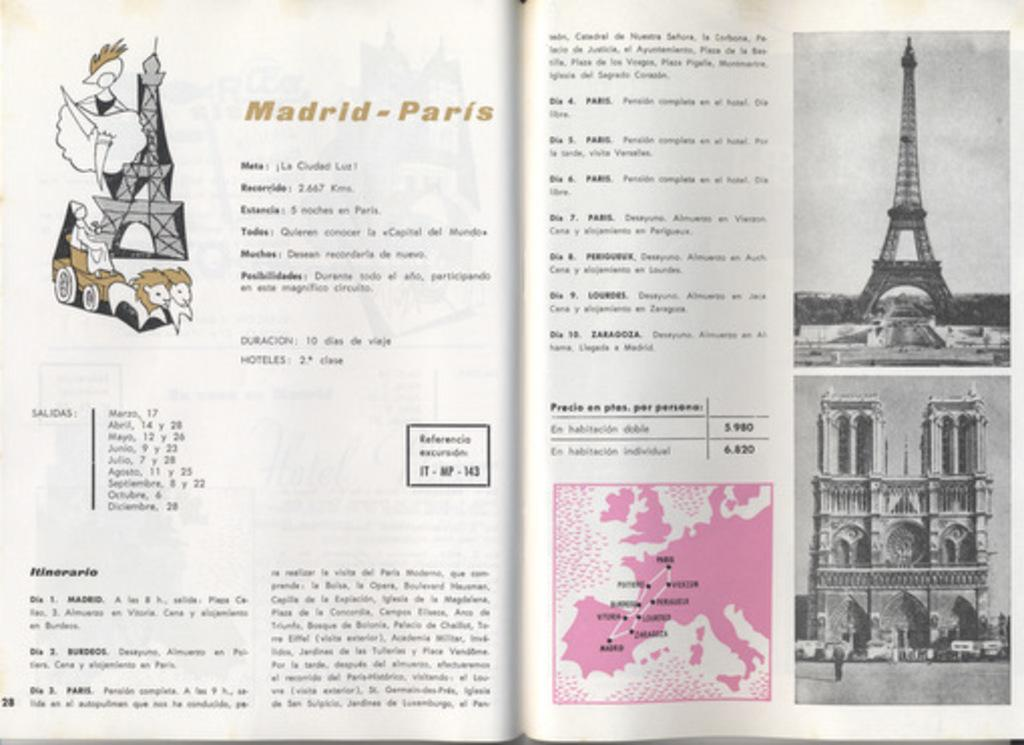What is the main object in the image? There is an open book in the image. What can be found within the open book? The open book contains images and text. What type of clouds can be seen in the images within the book? There is no information about clouds in the images within the book, as the facts provided do not mention any clouds. 